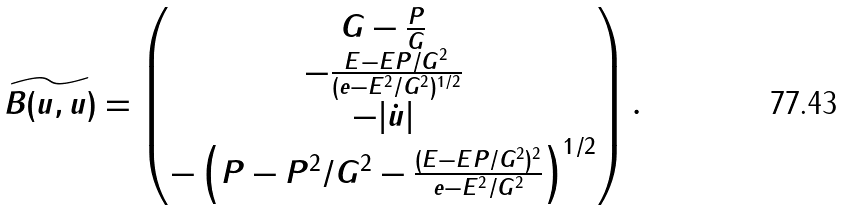<formula> <loc_0><loc_0><loc_500><loc_500>\widetilde { B ( u , u ) } = \begin{pmatrix} G - \frac { P } { G } \\ - \frac { E - E P / G ^ { 2 } } { ( e - E ^ { 2 } / G ^ { 2 } ) ^ { 1 / 2 } } \\ - | \dot { u } | \\ - \left ( P - P ^ { 2 } / G ^ { 2 } - \frac { ( E - E P / G ^ { 2 } ) ^ { 2 } } { e - E ^ { 2 } / G ^ { 2 } } \right ) ^ { 1 / 2 } \end{pmatrix} .</formula> 